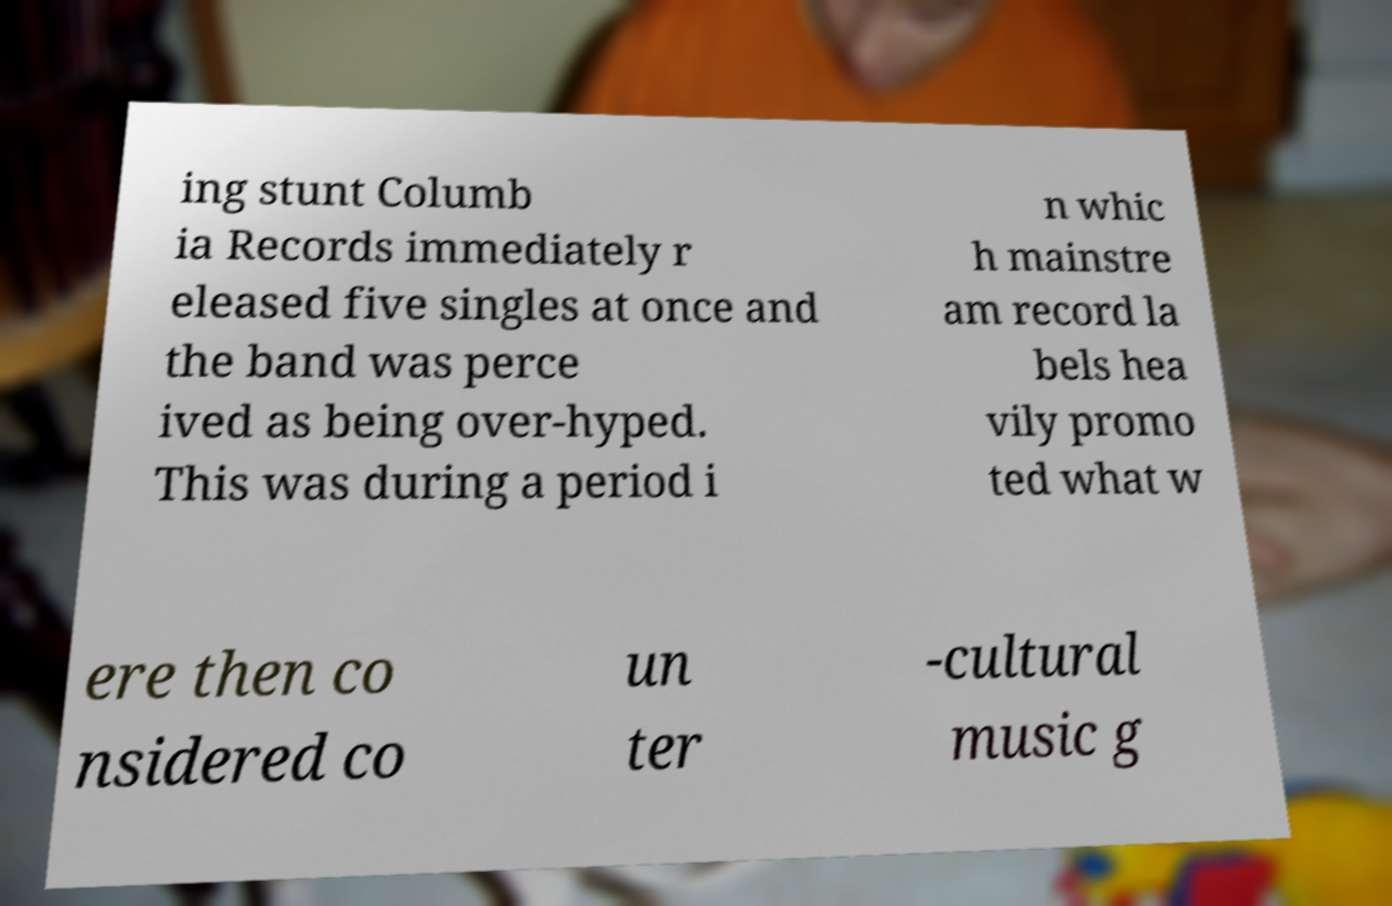For documentation purposes, I need the text within this image transcribed. Could you provide that? ing stunt Columb ia Records immediately r eleased five singles at once and the band was perce ived as being over-hyped. This was during a period i n whic h mainstre am record la bels hea vily promo ted what w ere then co nsidered co un ter -cultural music g 